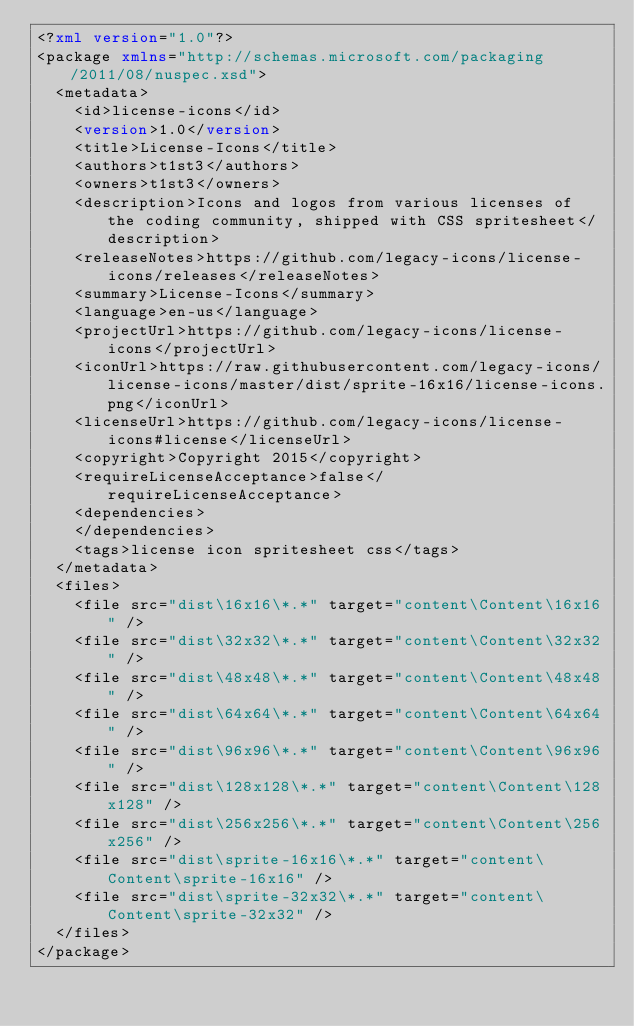<code> <loc_0><loc_0><loc_500><loc_500><_XML_><?xml version="1.0"?>
<package xmlns="http://schemas.microsoft.com/packaging/2011/08/nuspec.xsd">
  <metadata>
    <id>license-icons</id>
    <version>1.0</version>
    <title>License-Icons</title>
    <authors>t1st3</authors>
    <owners>t1st3</owners>
    <description>Icons and logos from various licenses of the coding community, shipped with CSS spritesheet</description>
    <releaseNotes>https://github.com/legacy-icons/license-icons/releases</releaseNotes>
    <summary>License-Icons</summary>
    <language>en-us</language>
    <projectUrl>https://github.com/legacy-icons/license-icons</projectUrl>
    <iconUrl>https://raw.githubusercontent.com/legacy-icons/license-icons/master/dist/sprite-16x16/license-icons.png</iconUrl>
    <licenseUrl>https://github.com/legacy-icons/license-icons#license</licenseUrl>
    <copyright>Copyright 2015</copyright>
    <requireLicenseAcceptance>false</requireLicenseAcceptance>
    <dependencies>
    </dependencies>
    <tags>license icon spritesheet css</tags>
  </metadata>
  <files>
    <file src="dist\16x16\*.*" target="content\Content\16x16" />
    <file src="dist\32x32\*.*" target="content\Content\32x32" />
    <file src="dist\48x48\*.*" target="content\Content\48x48" />
    <file src="dist\64x64\*.*" target="content\Content\64x64" />
    <file src="dist\96x96\*.*" target="content\Content\96x96" />
    <file src="dist\128x128\*.*" target="content\Content\128x128" />
    <file src="dist\256x256\*.*" target="content\Content\256x256" />
    <file src="dist\sprite-16x16\*.*" target="content\Content\sprite-16x16" />
    <file src="dist\sprite-32x32\*.*" target="content\Content\sprite-32x32" />
  </files>
</package>
</code> 